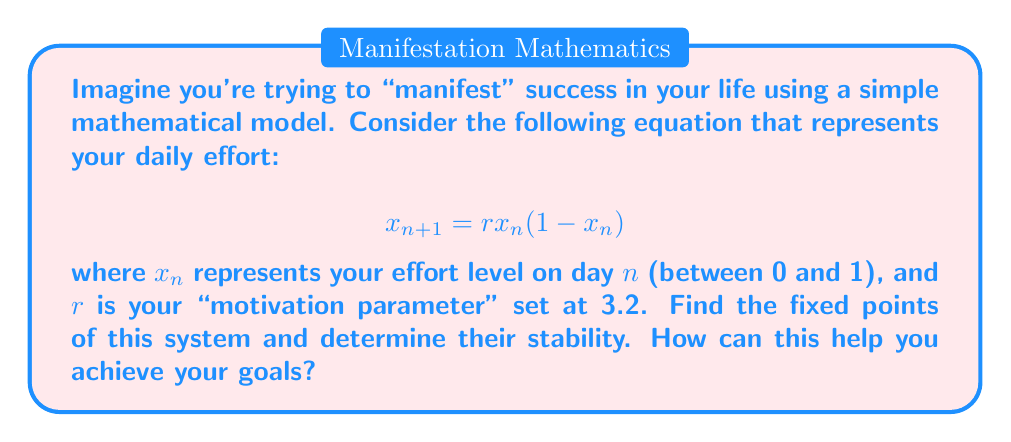Can you solve this math problem? Let's break this down step-by-step, just like we break down our goals:

1) Fixed points occur when $x_{n+1} = x_n = x^*$. So, we need to solve:
   $$x^* = rx^*(1-x^*)$$

2) Rearranging:
   $$x^* = rx^* - rx^{*2}$$
   $$0 = rx^* - rx^{*2} - x^*$$
   $$0 = x^*(r - rx^* - 1)$$

3) Solving this equation:
   Either $x^* = 0$ or $r - rx^* - 1 = 0$
   For the second case: $rx^* = r - 1$, so $x^* = 1 - \frac{1}{r}$

4) With $r = 3.2$, our fixed points are:
   $x^*_1 = 0$ and $x^*_2 = 1 - \frac{1}{3.2} = 0.6875$

5) To determine stability, we calculate $|f'(x^*)|$:
   $$f'(x) = r - 2rx$$
   
   For $x^*_1 = 0$: $|f'(0)| = |3.2| > 1$, so it's unstable.
   For $x^*_2 = 0.6875$: $|f'(0.6875)| = |3.2 - 2(3.2)(0.6875)| = 0.8 < 1$, so it's stable.

6) Interpretation: The stable fixed point at 0.6875 represents your ideal effort level. Consistently maintaining this effort will lead to steady progress towards your goals. The unstable fixed point at 0 represents the pitfall of giving up entirely, which you should avoid.
Answer: Fixed points: $x^*_1 = 0$ (unstable), $x^*_2 = 0.6875$ (stable) 